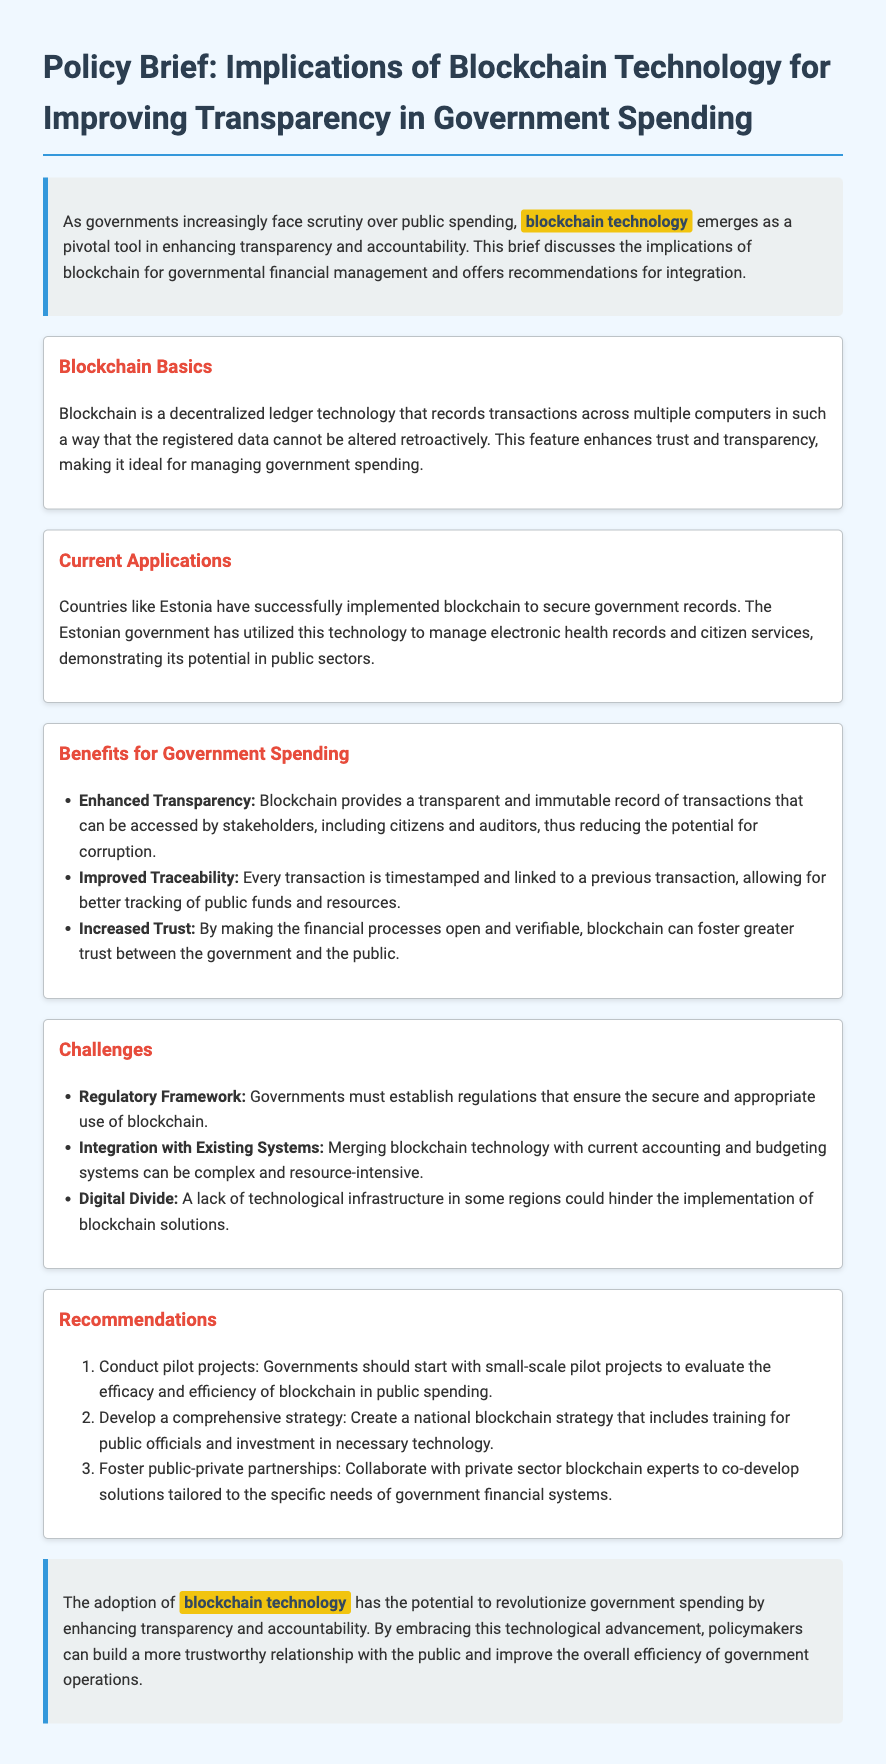What is the title of the policy brief? The title of the policy brief is clearly stated at the beginning of the document, which discusses the implications of blockchain technology.
Answer: Implications of Blockchain Technology for Improving Transparency in Government Spending What technology is highlighted in the brief? The technology highlighted is critical to the discussion on enhancing transparency and is referenced multiple times throughout the document.
Answer: Blockchain technology Which country is mentioned as having successfully implemented blockchain? The document cites a specific example of a country that has effectively used blockchain for governmental purposes.
Answer: Estonia What is one benefit of blockchain for government spending? The brief outlines several benefits, one of which is directly stated, improving transparency and accountability in financial transactions.
Answer: Enhanced Transparency What is one challenge associated with blockchain integration? The document lists potential challenges, specifying issues that need to be addressed for successful integration of blockchain technology.
Answer: Regulatory Framework How many recommendations are provided in the document? The recommendations section enumerates the suggested actions for implementation, allowing for a straightforward count.
Answer: Three What type of projects should governments conduct according to the recommendations? The recommendations specify a type of project that governments should initiate to test the effectiveness of blockchain technology.
Answer: Pilot projects What is the color associated with the headings in the document? The design of the document indicates a specific color used for headings, enhancing visual clarity and organization.
Answer: Dark blue 